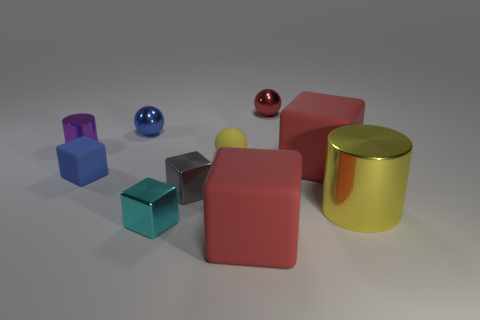How many other objects are the same color as the big metal thing?
Offer a very short reply. 1. Is there anything else that has the same size as the purple cylinder?
Offer a terse response. Yes. There is a small shiny cylinder; how many small metal spheres are behind it?
Your answer should be compact. 2. The shiny object that is behind the small blue thing behind the purple cylinder is what shape?
Keep it short and to the point. Sphere. Is there any other thing that is the same shape as the gray thing?
Offer a terse response. Yes. Are there more tiny metal balls that are right of the tiny gray cube than big red rubber blocks?
Provide a short and direct response. No. What number of blue metallic spheres are to the right of the large thing that is behind the small gray metal object?
Make the answer very short. 0. The big red rubber thing behind the red matte object that is on the left side of the red block on the right side of the small red object is what shape?
Ensure brevity in your answer.  Cube. The blue shiny thing has what size?
Ensure brevity in your answer.  Small. Are there any brown objects that have the same material as the big yellow cylinder?
Provide a succinct answer. No. 